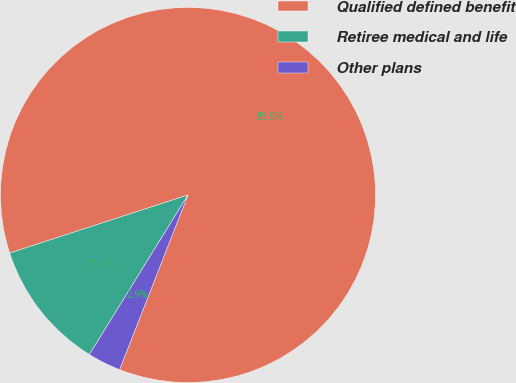Convert chart to OTSL. <chart><loc_0><loc_0><loc_500><loc_500><pie_chart><fcel>Qualified defined benefit<fcel>Retiree medical and life<fcel>Other plans<nl><fcel>85.95%<fcel>11.18%<fcel>2.87%<nl></chart> 